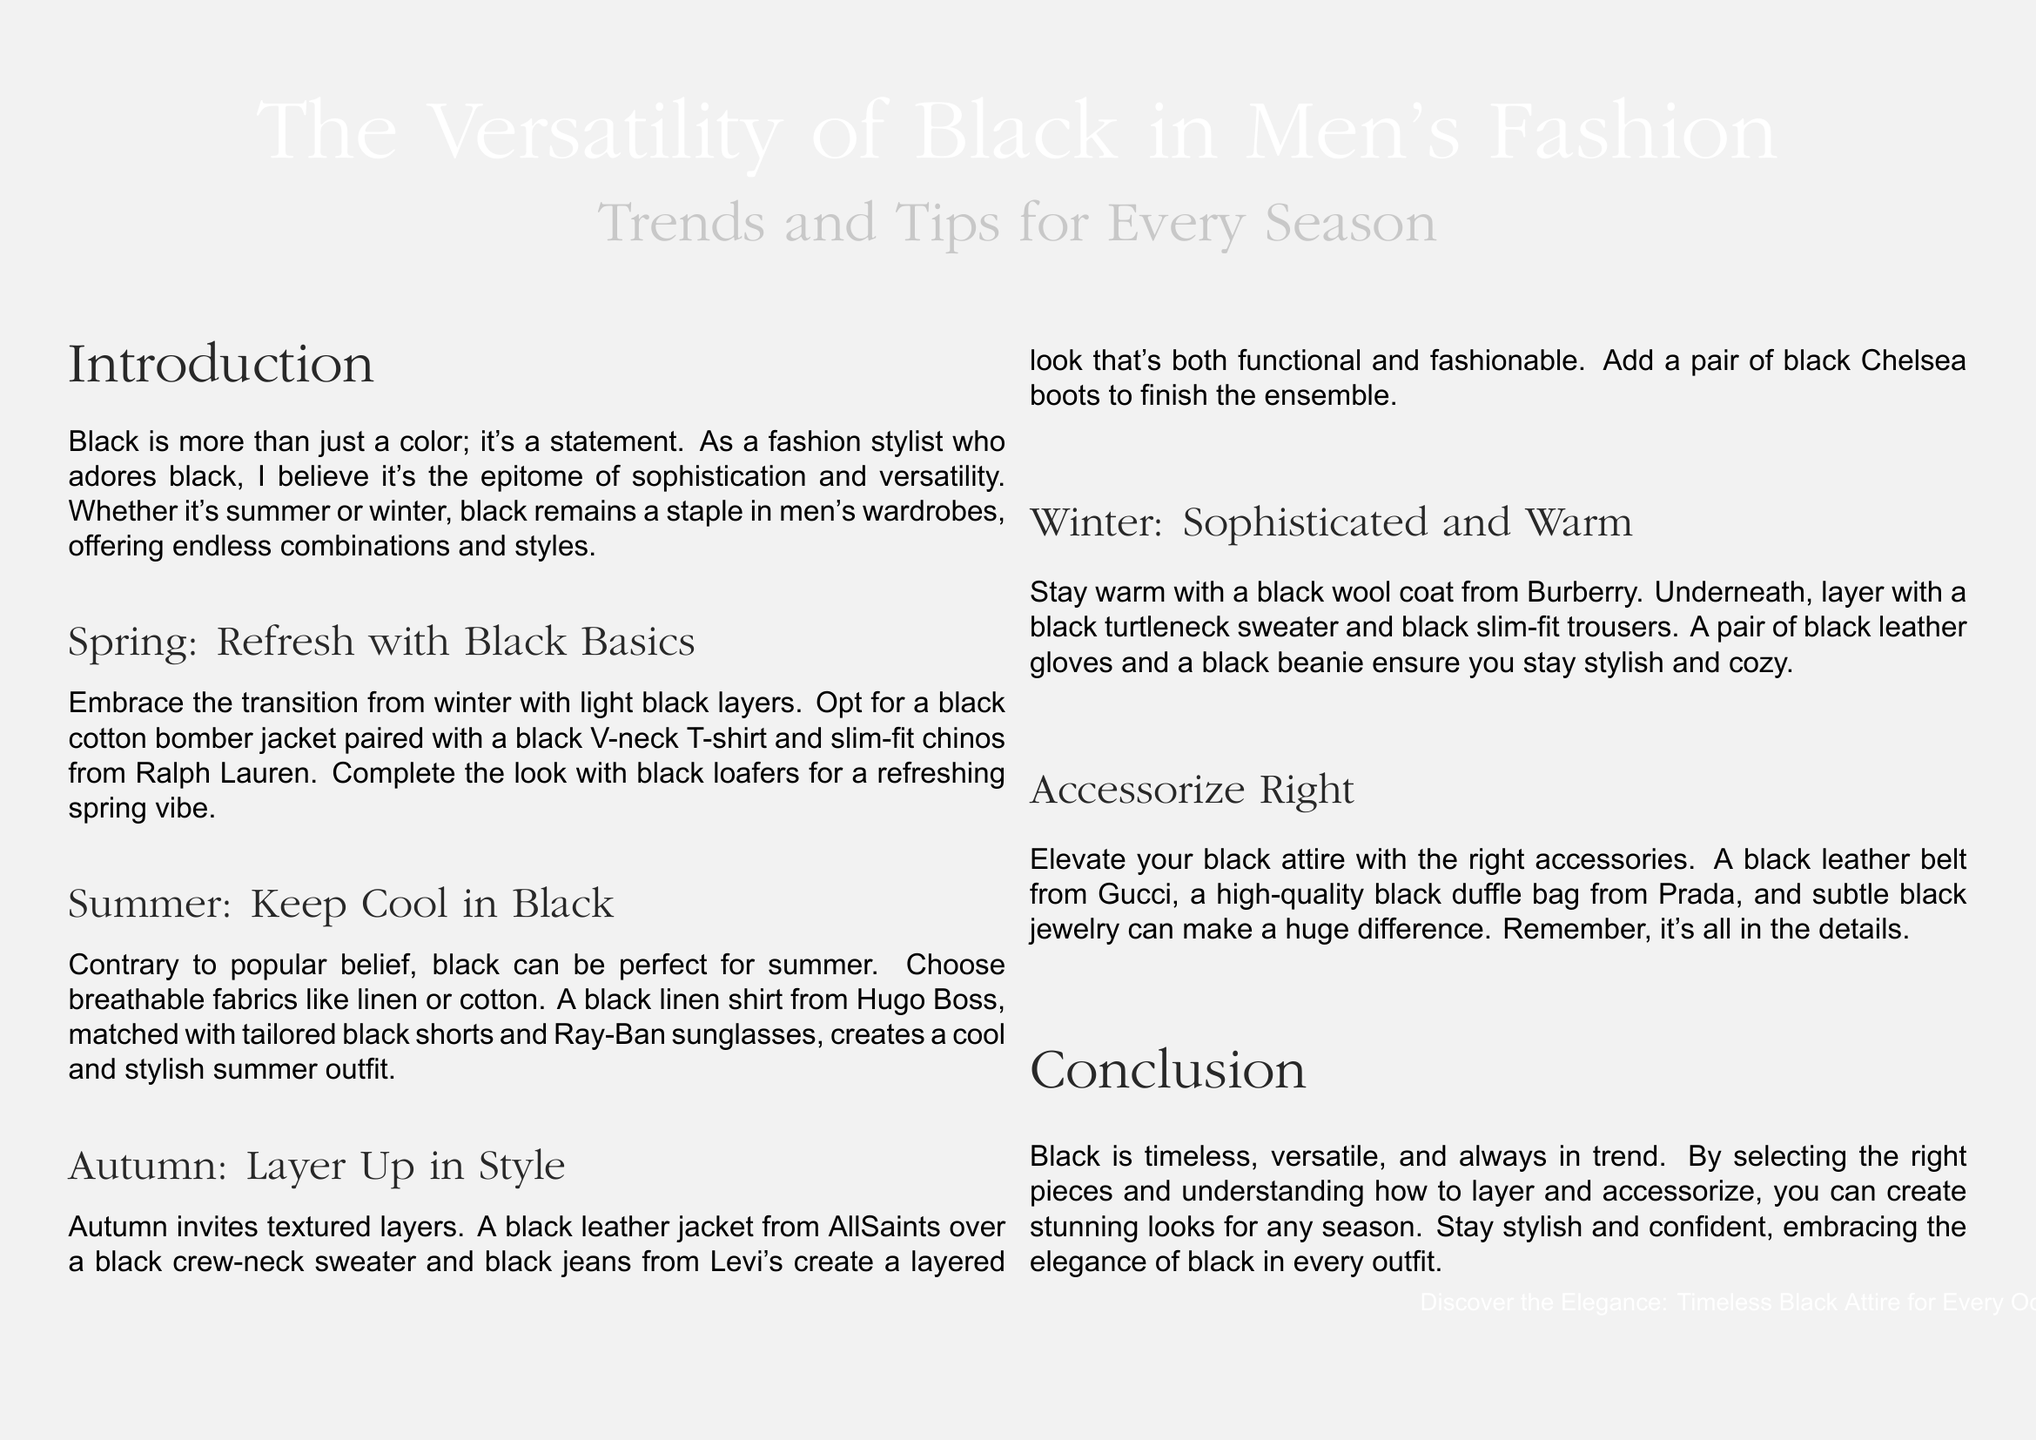What is the main theme of the document? The main theme is the versatility of black in men's fashion, highlighting trends and tips for different seasons.
Answer: The Versatility of Black in Men's Fashion What season is associated with black basics? The document indicates spring is the season for refreshing black basics.
Answer: Spring Which brand is mentioned for black loafers? The black loafers are mentioned in association with Ralph Lauren.
Answer: Ralph Lauren What type of fabric is recommended for summer black clothing? The document suggests breathable fabrics like linen or cotton for summer outfits.
Answer: Linen or cotton What is suggested for autumn layering? A black leather jacket over a black crew-neck sweater and black jeans is suggested for autumn.
Answer: Black leather jacket Which accessory is mentioned to elevate black attire? A black leather belt from Gucci is mentioned as an accessory to elevate black attire.
Answer: Black leather belt What type of item is a black beanie considered for winter? The black beanie is considered an accessory to ensure warmth and style in winter.
Answer: Accessory What conclusion is drawn about the color black? The conclusion highlights black as timeless and versatile in men's fashion.
Answer: Timeless and versatile How does the document describe black clothing for every occasion? It describes black clothing as elegant and appropriate for any setting.
Answer: Elegant 